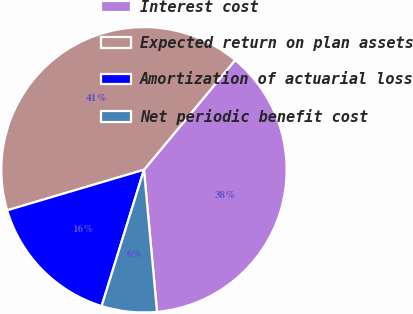<chart> <loc_0><loc_0><loc_500><loc_500><pie_chart><fcel>Interest cost<fcel>Expected return on plan assets<fcel>Amortization of actuarial loss<fcel>Net periodic benefit cost<nl><fcel>37.5%<fcel>40.62%<fcel>15.62%<fcel>6.25%<nl></chart> 